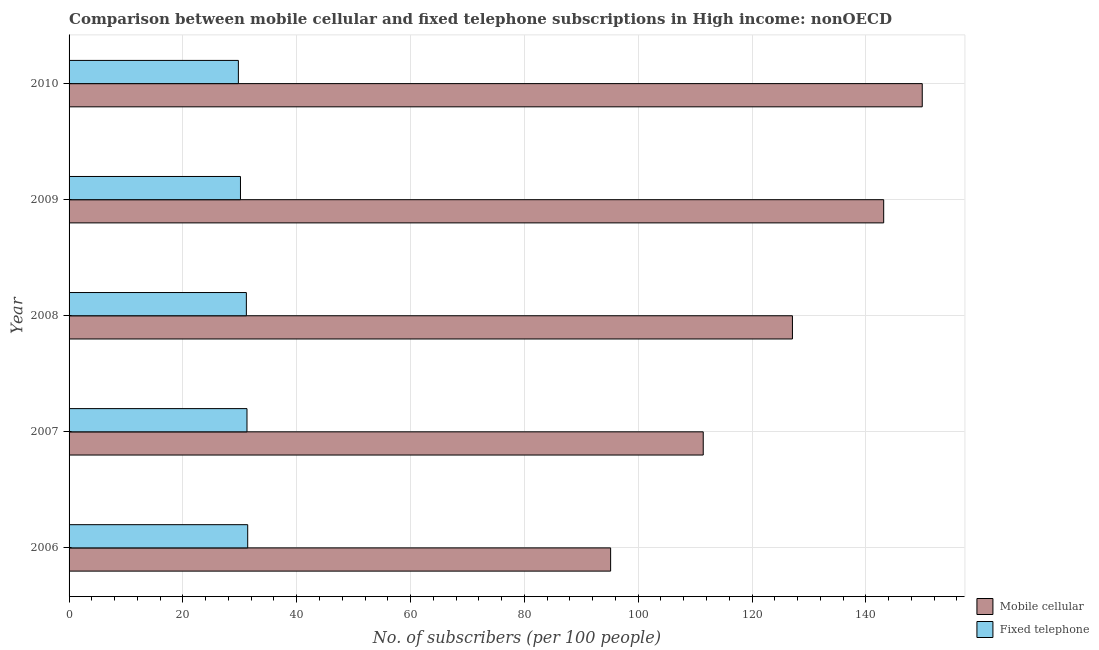Are the number of bars per tick equal to the number of legend labels?
Your response must be concise. Yes. Are the number of bars on each tick of the Y-axis equal?
Keep it short and to the point. Yes. How many bars are there on the 1st tick from the top?
Offer a terse response. 2. What is the label of the 5th group of bars from the top?
Offer a terse response. 2006. What is the number of fixed telephone subscribers in 2007?
Your answer should be compact. 31.26. Across all years, what is the maximum number of mobile cellular subscribers?
Your response must be concise. 149.92. Across all years, what is the minimum number of mobile cellular subscribers?
Keep it short and to the point. 95.16. What is the total number of fixed telephone subscribers in the graph?
Keep it short and to the point. 153.67. What is the difference between the number of fixed telephone subscribers in 2008 and that in 2010?
Provide a short and direct response. 1.4. What is the difference between the number of fixed telephone subscribers in 2008 and the number of mobile cellular subscribers in 2010?
Your answer should be very brief. -118.76. What is the average number of fixed telephone subscribers per year?
Offer a very short reply. 30.73. In the year 2007, what is the difference between the number of fixed telephone subscribers and number of mobile cellular subscribers?
Make the answer very short. -80.17. In how many years, is the number of fixed telephone subscribers greater than 132 ?
Offer a very short reply. 0. What is the ratio of the number of mobile cellular subscribers in 2006 to that in 2007?
Your response must be concise. 0.85. Is the number of fixed telephone subscribers in 2007 less than that in 2008?
Ensure brevity in your answer.  No. What is the difference between the highest and the second highest number of mobile cellular subscribers?
Make the answer very short. 6.78. What is the difference between the highest and the lowest number of mobile cellular subscribers?
Offer a terse response. 54.76. In how many years, is the number of fixed telephone subscribers greater than the average number of fixed telephone subscribers taken over all years?
Offer a terse response. 3. Is the sum of the number of mobile cellular subscribers in 2007 and 2010 greater than the maximum number of fixed telephone subscribers across all years?
Keep it short and to the point. Yes. What does the 2nd bar from the top in 2009 represents?
Your answer should be compact. Mobile cellular. What does the 1st bar from the bottom in 2007 represents?
Your answer should be compact. Mobile cellular. How many bars are there?
Ensure brevity in your answer.  10. How many years are there in the graph?
Offer a terse response. 5. What is the difference between two consecutive major ticks on the X-axis?
Offer a terse response. 20. Are the values on the major ticks of X-axis written in scientific E-notation?
Your answer should be very brief. No. What is the title of the graph?
Offer a terse response. Comparison between mobile cellular and fixed telephone subscriptions in High income: nonOECD. What is the label or title of the X-axis?
Ensure brevity in your answer.  No. of subscribers (per 100 people). What is the label or title of the Y-axis?
Give a very brief answer. Year. What is the No. of subscribers (per 100 people) of Mobile cellular in 2006?
Offer a very short reply. 95.16. What is the No. of subscribers (per 100 people) of Fixed telephone in 2006?
Give a very brief answer. 31.39. What is the No. of subscribers (per 100 people) of Mobile cellular in 2007?
Keep it short and to the point. 111.43. What is the No. of subscribers (per 100 people) in Fixed telephone in 2007?
Your answer should be compact. 31.26. What is the No. of subscribers (per 100 people) in Mobile cellular in 2008?
Ensure brevity in your answer.  127.11. What is the No. of subscribers (per 100 people) of Fixed telephone in 2008?
Your answer should be compact. 31.15. What is the No. of subscribers (per 100 people) in Mobile cellular in 2009?
Provide a short and direct response. 143.14. What is the No. of subscribers (per 100 people) of Fixed telephone in 2009?
Keep it short and to the point. 30.12. What is the No. of subscribers (per 100 people) of Mobile cellular in 2010?
Make the answer very short. 149.92. What is the No. of subscribers (per 100 people) in Fixed telephone in 2010?
Your answer should be very brief. 29.75. Across all years, what is the maximum No. of subscribers (per 100 people) in Mobile cellular?
Provide a short and direct response. 149.92. Across all years, what is the maximum No. of subscribers (per 100 people) of Fixed telephone?
Make the answer very short. 31.39. Across all years, what is the minimum No. of subscribers (per 100 people) in Mobile cellular?
Provide a short and direct response. 95.16. Across all years, what is the minimum No. of subscribers (per 100 people) of Fixed telephone?
Your response must be concise. 29.75. What is the total No. of subscribers (per 100 people) of Mobile cellular in the graph?
Make the answer very short. 626.75. What is the total No. of subscribers (per 100 people) in Fixed telephone in the graph?
Make the answer very short. 153.67. What is the difference between the No. of subscribers (per 100 people) in Mobile cellular in 2006 and that in 2007?
Offer a very short reply. -16.27. What is the difference between the No. of subscribers (per 100 people) in Fixed telephone in 2006 and that in 2007?
Make the answer very short. 0.13. What is the difference between the No. of subscribers (per 100 people) of Mobile cellular in 2006 and that in 2008?
Make the answer very short. -31.95. What is the difference between the No. of subscribers (per 100 people) in Fixed telephone in 2006 and that in 2008?
Make the answer very short. 0.24. What is the difference between the No. of subscribers (per 100 people) in Mobile cellular in 2006 and that in 2009?
Make the answer very short. -47.98. What is the difference between the No. of subscribers (per 100 people) in Fixed telephone in 2006 and that in 2009?
Give a very brief answer. 1.27. What is the difference between the No. of subscribers (per 100 people) in Mobile cellular in 2006 and that in 2010?
Offer a terse response. -54.76. What is the difference between the No. of subscribers (per 100 people) of Fixed telephone in 2006 and that in 2010?
Your answer should be very brief. 1.64. What is the difference between the No. of subscribers (per 100 people) of Mobile cellular in 2007 and that in 2008?
Your answer should be compact. -15.68. What is the difference between the No. of subscribers (per 100 people) of Fixed telephone in 2007 and that in 2008?
Make the answer very short. 0.11. What is the difference between the No. of subscribers (per 100 people) of Mobile cellular in 2007 and that in 2009?
Give a very brief answer. -31.71. What is the difference between the No. of subscribers (per 100 people) of Fixed telephone in 2007 and that in 2009?
Keep it short and to the point. 1.14. What is the difference between the No. of subscribers (per 100 people) of Mobile cellular in 2007 and that in 2010?
Your answer should be compact. -38.49. What is the difference between the No. of subscribers (per 100 people) of Fixed telephone in 2007 and that in 2010?
Your response must be concise. 1.51. What is the difference between the No. of subscribers (per 100 people) of Mobile cellular in 2008 and that in 2009?
Provide a succinct answer. -16.04. What is the difference between the No. of subscribers (per 100 people) of Fixed telephone in 2008 and that in 2009?
Your response must be concise. 1.03. What is the difference between the No. of subscribers (per 100 people) in Mobile cellular in 2008 and that in 2010?
Your answer should be compact. -22.81. What is the difference between the No. of subscribers (per 100 people) of Fixed telephone in 2008 and that in 2010?
Keep it short and to the point. 1.4. What is the difference between the No. of subscribers (per 100 people) in Mobile cellular in 2009 and that in 2010?
Keep it short and to the point. -6.78. What is the difference between the No. of subscribers (per 100 people) of Fixed telephone in 2009 and that in 2010?
Your answer should be very brief. 0.37. What is the difference between the No. of subscribers (per 100 people) in Mobile cellular in 2006 and the No. of subscribers (per 100 people) in Fixed telephone in 2007?
Your answer should be very brief. 63.9. What is the difference between the No. of subscribers (per 100 people) in Mobile cellular in 2006 and the No. of subscribers (per 100 people) in Fixed telephone in 2008?
Make the answer very short. 64.01. What is the difference between the No. of subscribers (per 100 people) in Mobile cellular in 2006 and the No. of subscribers (per 100 people) in Fixed telephone in 2009?
Give a very brief answer. 65.04. What is the difference between the No. of subscribers (per 100 people) of Mobile cellular in 2006 and the No. of subscribers (per 100 people) of Fixed telephone in 2010?
Your answer should be very brief. 65.41. What is the difference between the No. of subscribers (per 100 people) in Mobile cellular in 2007 and the No. of subscribers (per 100 people) in Fixed telephone in 2008?
Your answer should be very brief. 80.28. What is the difference between the No. of subscribers (per 100 people) in Mobile cellular in 2007 and the No. of subscribers (per 100 people) in Fixed telephone in 2009?
Ensure brevity in your answer.  81.31. What is the difference between the No. of subscribers (per 100 people) in Mobile cellular in 2007 and the No. of subscribers (per 100 people) in Fixed telephone in 2010?
Ensure brevity in your answer.  81.68. What is the difference between the No. of subscribers (per 100 people) in Mobile cellular in 2008 and the No. of subscribers (per 100 people) in Fixed telephone in 2009?
Make the answer very short. 96.99. What is the difference between the No. of subscribers (per 100 people) in Mobile cellular in 2008 and the No. of subscribers (per 100 people) in Fixed telephone in 2010?
Make the answer very short. 97.36. What is the difference between the No. of subscribers (per 100 people) in Mobile cellular in 2009 and the No. of subscribers (per 100 people) in Fixed telephone in 2010?
Your response must be concise. 113.39. What is the average No. of subscribers (per 100 people) in Mobile cellular per year?
Provide a short and direct response. 125.35. What is the average No. of subscribers (per 100 people) in Fixed telephone per year?
Give a very brief answer. 30.73. In the year 2006, what is the difference between the No. of subscribers (per 100 people) in Mobile cellular and No. of subscribers (per 100 people) in Fixed telephone?
Your answer should be compact. 63.77. In the year 2007, what is the difference between the No. of subscribers (per 100 people) of Mobile cellular and No. of subscribers (per 100 people) of Fixed telephone?
Ensure brevity in your answer.  80.17. In the year 2008, what is the difference between the No. of subscribers (per 100 people) in Mobile cellular and No. of subscribers (per 100 people) in Fixed telephone?
Provide a succinct answer. 95.95. In the year 2009, what is the difference between the No. of subscribers (per 100 people) in Mobile cellular and No. of subscribers (per 100 people) in Fixed telephone?
Provide a short and direct response. 113.02. In the year 2010, what is the difference between the No. of subscribers (per 100 people) in Mobile cellular and No. of subscribers (per 100 people) in Fixed telephone?
Your answer should be very brief. 120.17. What is the ratio of the No. of subscribers (per 100 people) of Mobile cellular in 2006 to that in 2007?
Keep it short and to the point. 0.85. What is the ratio of the No. of subscribers (per 100 people) of Fixed telephone in 2006 to that in 2007?
Keep it short and to the point. 1. What is the ratio of the No. of subscribers (per 100 people) in Mobile cellular in 2006 to that in 2008?
Offer a very short reply. 0.75. What is the ratio of the No. of subscribers (per 100 people) of Fixed telephone in 2006 to that in 2008?
Offer a terse response. 1.01. What is the ratio of the No. of subscribers (per 100 people) of Mobile cellular in 2006 to that in 2009?
Your answer should be very brief. 0.66. What is the ratio of the No. of subscribers (per 100 people) of Fixed telephone in 2006 to that in 2009?
Offer a terse response. 1.04. What is the ratio of the No. of subscribers (per 100 people) in Mobile cellular in 2006 to that in 2010?
Offer a very short reply. 0.63. What is the ratio of the No. of subscribers (per 100 people) of Fixed telephone in 2006 to that in 2010?
Provide a short and direct response. 1.06. What is the ratio of the No. of subscribers (per 100 people) of Mobile cellular in 2007 to that in 2008?
Keep it short and to the point. 0.88. What is the ratio of the No. of subscribers (per 100 people) of Mobile cellular in 2007 to that in 2009?
Your response must be concise. 0.78. What is the ratio of the No. of subscribers (per 100 people) of Fixed telephone in 2007 to that in 2009?
Your response must be concise. 1.04. What is the ratio of the No. of subscribers (per 100 people) in Mobile cellular in 2007 to that in 2010?
Offer a terse response. 0.74. What is the ratio of the No. of subscribers (per 100 people) in Fixed telephone in 2007 to that in 2010?
Provide a short and direct response. 1.05. What is the ratio of the No. of subscribers (per 100 people) of Mobile cellular in 2008 to that in 2009?
Your response must be concise. 0.89. What is the ratio of the No. of subscribers (per 100 people) of Fixed telephone in 2008 to that in 2009?
Provide a short and direct response. 1.03. What is the ratio of the No. of subscribers (per 100 people) of Mobile cellular in 2008 to that in 2010?
Offer a terse response. 0.85. What is the ratio of the No. of subscribers (per 100 people) in Fixed telephone in 2008 to that in 2010?
Your answer should be compact. 1.05. What is the ratio of the No. of subscribers (per 100 people) in Mobile cellular in 2009 to that in 2010?
Your answer should be compact. 0.95. What is the ratio of the No. of subscribers (per 100 people) of Fixed telephone in 2009 to that in 2010?
Your response must be concise. 1.01. What is the difference between the highest and the second highest No. of subscribers (per 100 people) of Mobile cellular?
Keep it short and to the point. 6.78. What is the difference between the highest and the second highest No. of subscribers (per 100 people) of Fixed telephone?
Offer a very short reply. 0.13. What is the difference between the highest and the lowest No. of subscribers (per 100 people) of Mobile cellular?
Ensure brevity in your answer.  54.76. What is the difference between the highest and the lowest No. of subscribers (per 100 people) in Fixed telephone?
Your answer should be compact. 1.64. 